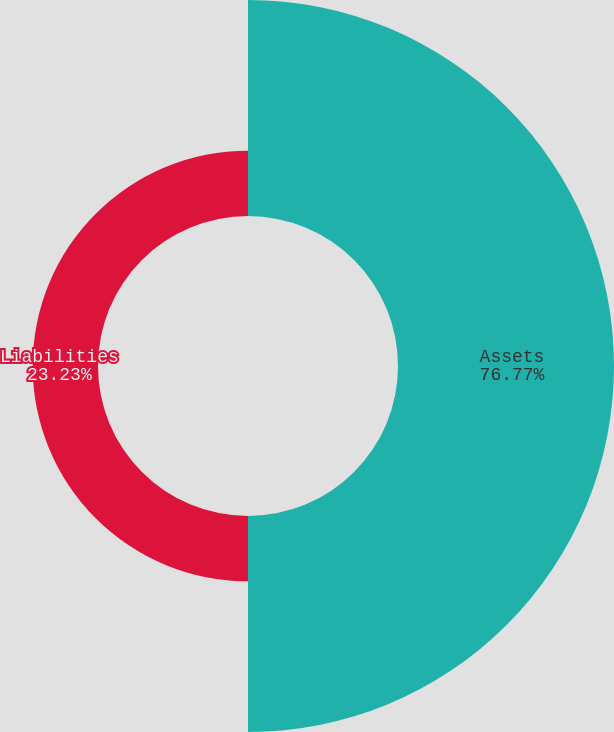Convert chart. <chart><loc_0><loc_0><loc_500><loc_500><pie_chart><fcel>Assets<fcel>Liabilities<nl><fcel>76.77%<fcel>23.23%<nl></chart> 